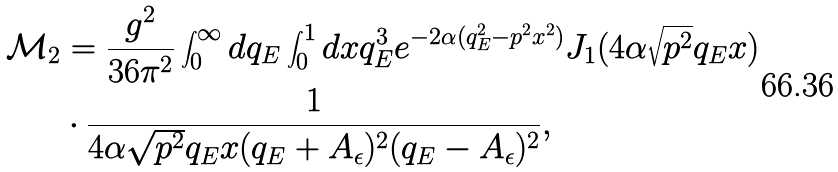<formula> <loc_0><loc_0><loc_500><loc_500>\mathcal { M } _ { 2 } & = \frac { g ^ { 2 } } { 3 6 \pi ^ { 2 } } \int _ { 0 } ^ { \infty } d q _ { E } \int _ { 0 } ^ { 1 } d x q _ { E } ^ { 3 } e ^ { - 2 \alpha ( q _ { E } ^ { 2 } - p ^ { 2 } x ^ { 2 } ) } J _ { 1 } ( 4 \alpha \sqrt { p ^ { 2 } } q _ { E } x ) \\ & \cdot \frac { 1 } { 4 \alpha \sqrt { p ^ { 2 } } q _ { E } x ( q _ { E } + A _ { \epsilon } ) ^ { 2 } ( q _ { E } - A _ { \epsilon } ) ^ { 2 } } ,</formula> 